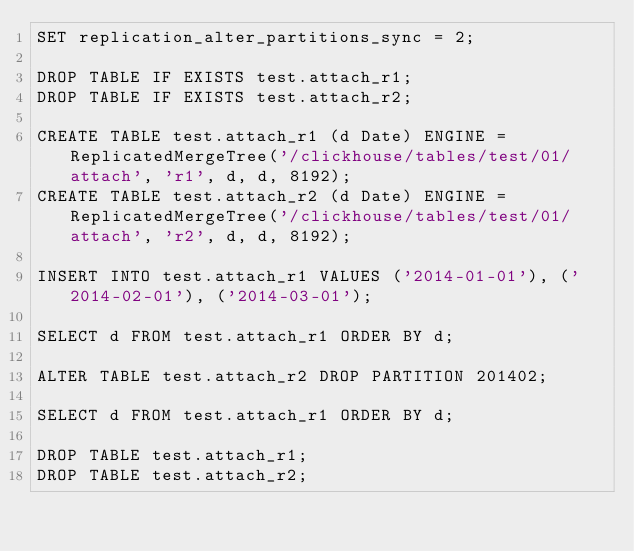Convert code to text. <code><loc_0><loc_0><loc_500><loc_500><_SQL_>SET replication_alter_partitions_sync = 2;

DROP TABLE IF EXISTS test.attach_r1;
DROP TABLE IF EXISTS test.attach_r2;

CREATE TABLE test.attach_r1 (d Date) ENGINE = ReplicatedMergeTree('/clickhouse/tables/test/01/attach', 'r1', d, d, 8192);
CREATE TABLE test.attach_r2 (d Date) ENGINE = ReplicatedMergeTree('/clickhouse/tables/test/01/attach', 'r2', d, d, 8192);

INSERT INTO test.attach_r1 VALUES ('2014-01-01'), ('2014-02-01'), ('2014-03-01');

SELECT d FROM test.attach_r1 ORDER BY d;

ALTER TABLE test.attach_r2 DROP PARTITION 201402;

SELECT d FROM test.attach_r1 ORDER BY d;

DROP TABLE test.attach_r1;
DROP TABLE test.attach_r2;
</code> 